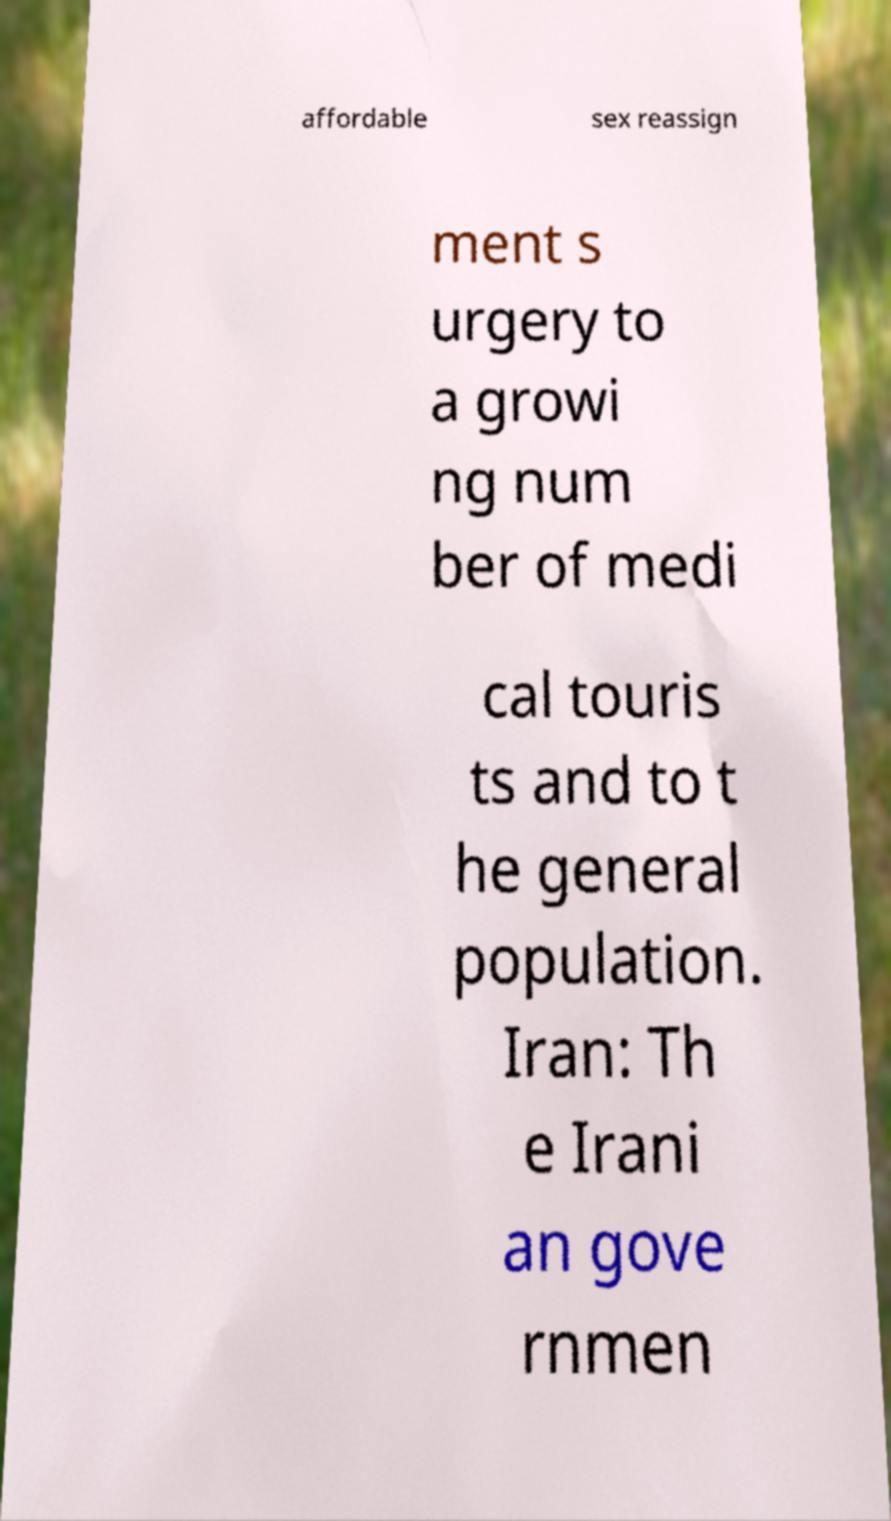Can you read and provide the text displayed in the image?This photo seems to have some interesting text. Can you extract and type it out for me? affordable sex reassign ment s urgery to a growi ng num ber of medi cal touris ts and to t he general population. Iran: Th e Irani an gove rnmen 